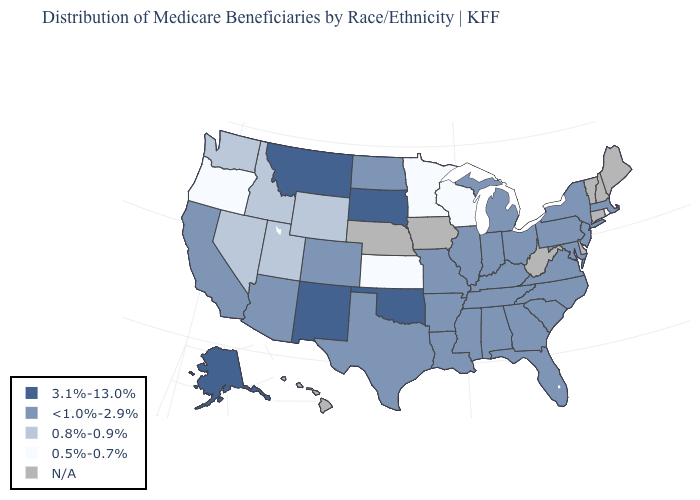Which states hav the highest value in the Northeast?
Give a very brief answer. Massachusetts, New Jersey, New York, Pennsylvania. What is the value of Georgia?
Be succinct. <1.0%-2.9%. Name the states that have a value in the range 0.5%-0.7%?
Quick response, please. Kansas, Minnesota, Oregon, Rhode Island, Wisconsin. What is the value of Oklahoma?
Answer briefly. 3.1%-13.0%. What is the highest value in the USA?
Concise answer only. 3.1%-13.0%. Is the legend a continuous bar?
Keep it brief. No. Which states have the lowest value in the USA?
Concise answer only. Kansas, Minnesota, Oregon, Rhode Island, Wisconsin. Does Tennessee have the highest value in the USA?
Short answer required. No. Does Texas have the highest value in the USA?
Answer briefly. No. What is the highest value in states that border Kentucky?
Short answer required. <1.0%-2.9%. What is the value of Iowa?
Short answer required. N/A. Name the states that have a value in the range <1.0%-2.9%?
Be succinct. Alabama, Arizona, Arkansas, California, Colorado, Florida, Georgia, Illinois, Indiana, Kentucky, Louisiana, Maryland, Massachusetts, Michigan, Mississippi, Missouri, New Jersey, New York, North Carolina, North Dakota, Ohio, Pennsylvania, South Carolina, Tennessee, Texas, Virginia. What is the lowest value in states that border Wisconsin?
Quick response, please. 0.5%-0.7%. What is the value of North Carolina?
Be succinct. <1.0%-2.9%. 